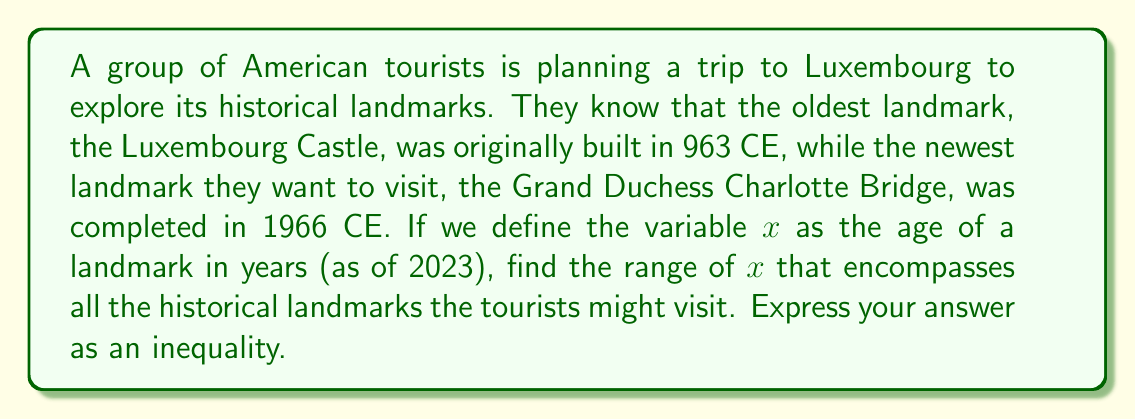Show me your answer to this math problem. To solve this problem, we need to follow these steps:

1) First, let's calculate the age of the oldest landmark (Luxembourg Castle):
   $2023 - 963 = 1060$ years old

2) Now, let's calculate the age of the newest landmark (Grand Duchess Charlotte Bridge):
   $2023 - 1966 = 57$ years old

3) Since $x$ represents the age of a landmark, the youngest landmark will have the smallest value of $x$, and the oldest landmark will have the largest value of $x$.

4) Therefore, we can express this as an inequality:
   $57 \leq x \leq 1060$

This inequality means that the age of any historical landmark the tourists might visit is at least 57 years and at most 1060 years.

5) We can also express this in interval notation as:
   $x \in [57, 1060]$

This reads as "$x$ is an element of the closed interval from 57 to 1060".
Answer: $57 \leq x \leq 1060$, where $x$ is the age of a landmark in years. 